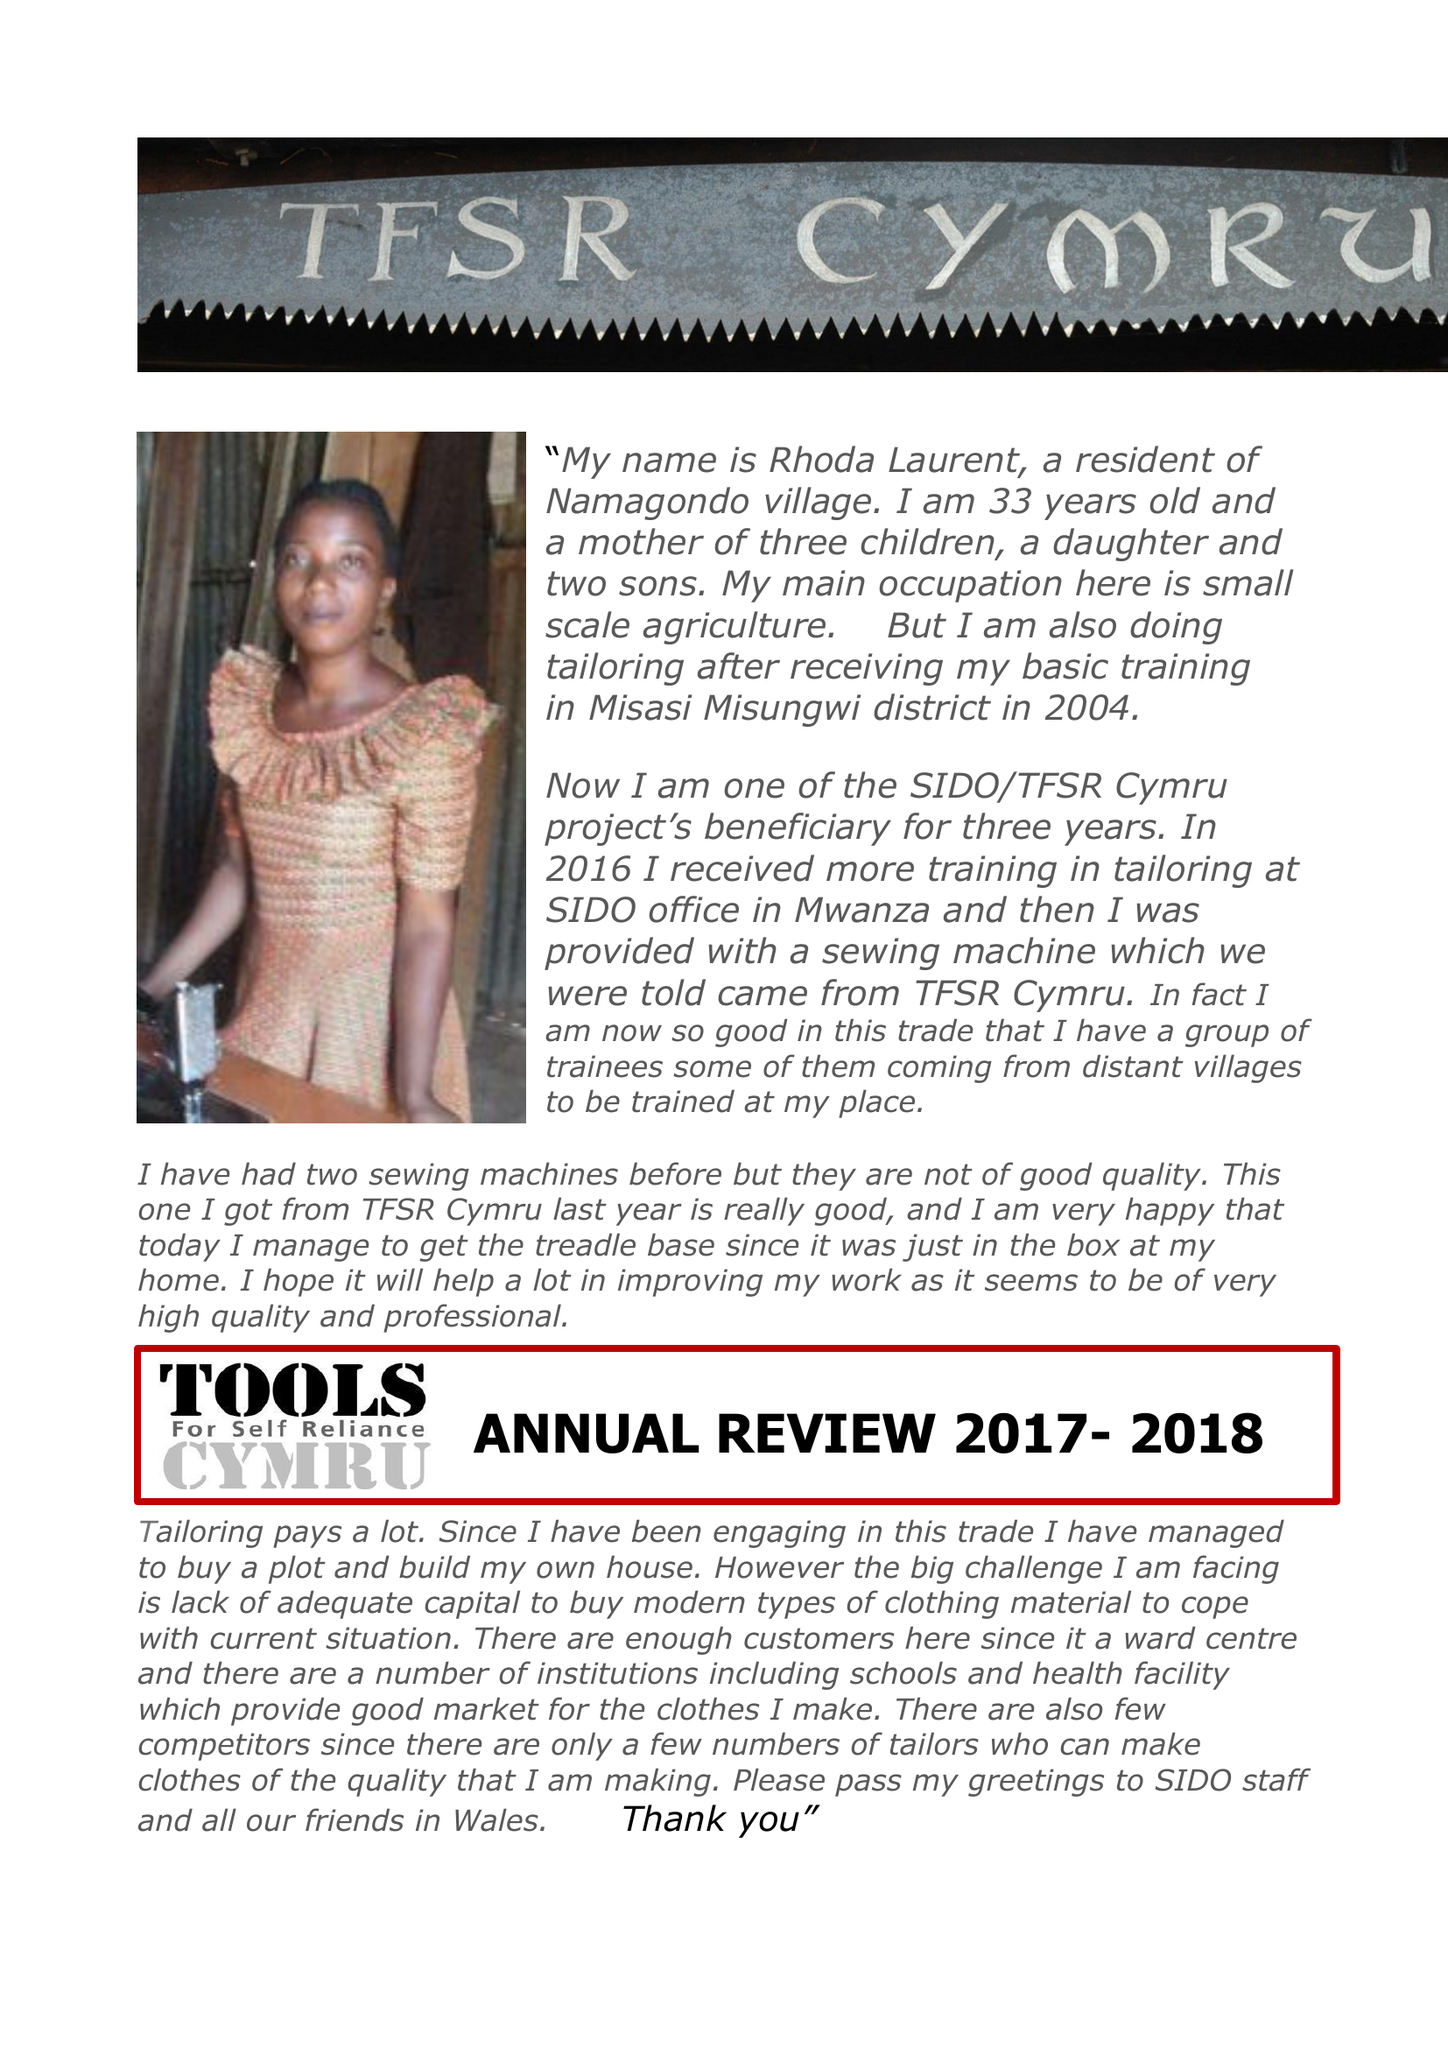What is the value for the charity_name?
Answer the question using a single word or phrase. Tools For Self Reliance Cymru Ltd. 